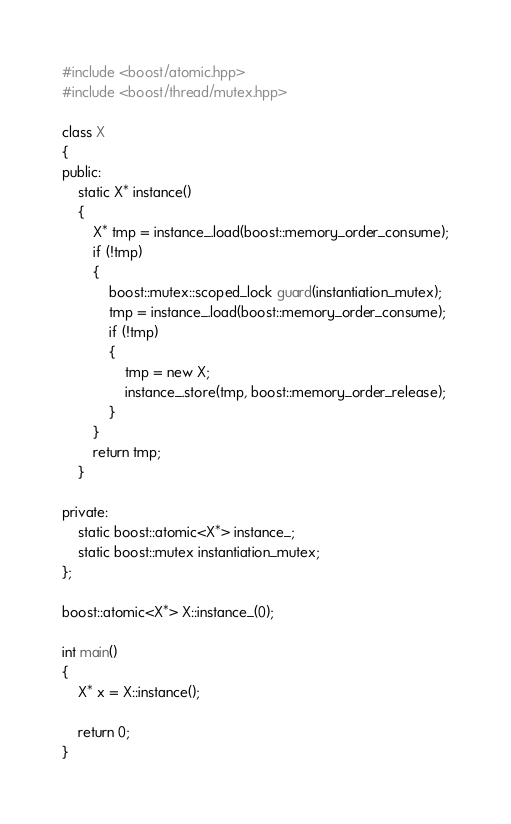Convert code to text. <code><loc_0><loc_0><loc_500><loc_500><_C++_>#include <boost/atomic.hpp>
#include <boost/thread/mutex.hpp>

class X
{
public:
	static X* instance()
	{
		X* tmp = instance_.load(boost::memory_order_consume);
		if (!tmp)
		{
			boost::mutex::scoped_lock guard(instantiation_mutex);
			tmp = instance_.load(boost::memory_order_consume);
			if (!tmp)
			{
				tmp = new X;
				instance_.store(tmp, boost::memory_order_release);
			}
		}
		return tmp;
	}

private:
	static boost::atomic<X*> instance_;
	static boost::mutex instantiation_mutex;
};

boost::atomic<X*> X::instance_(0);

int main()
{
	X* x = X::instance();

	return 0;
}
</code> 